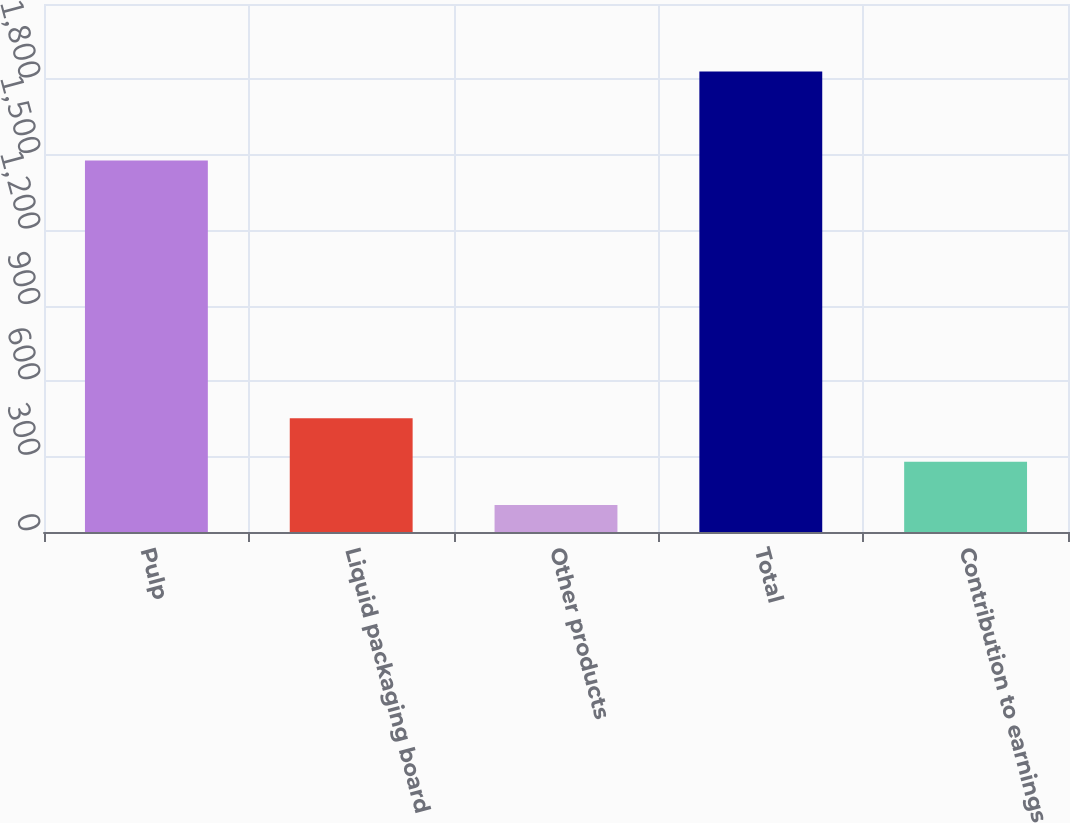<chart> <loc_0><loc_0><loc_500><loc_500><bar_chart><fcel>Pulp<fcel>Liquid packaging board<fcel>Other products<fcel>Total<fcel>Contribution to earnings<nl><fcel>1478<fcel>452<fcel>107<fcel>1832<fcel>279.5<nl></chart> 